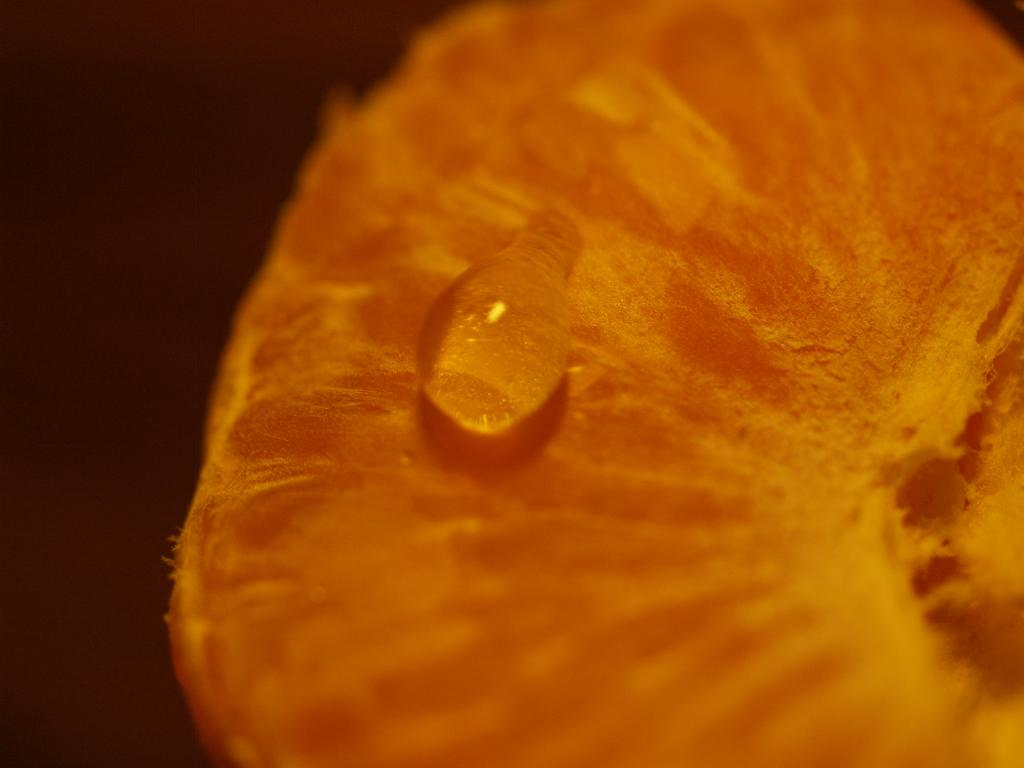What is the main subject of the image? The main subject of the image is a water drop. Where is the water drop located? The water drop is on an orange slice. What type of wound can be seen on the head of the person in the image? There is no person or wound present in the image; it features a water drop on an orange slice. 